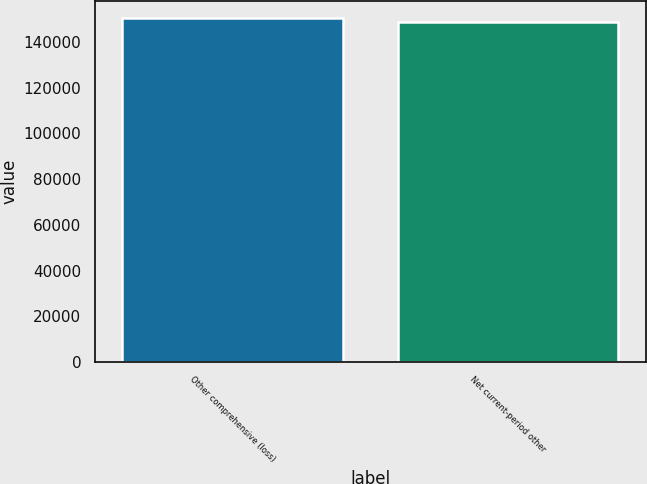Convert chart to OTSL. <chart><loc_0><loc_0><loc_500><loc_500><bar_chart><fcel>Other comprehensive (loss)<fcel>Net current-period other<nl><fcel>150357<fcel>148580<nl></chart> 